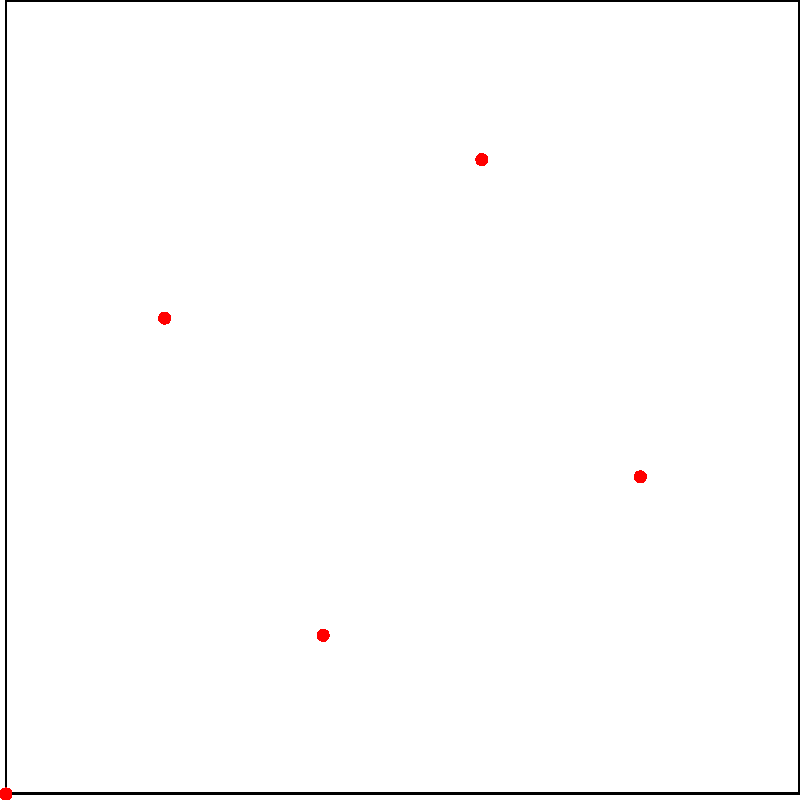На футбольном поле размером 5x5 расположены пять игроков (A, B, C, D, E) в различных позициях, как показано на диаграмме. Используя диаграмму Вороного, определите, какой игрок контролирует наибольшую площадь поля. Предположим, что все игроки имеют одинаковую скорость и способность покрывать территорию. Чтобы решить эту задачу, давайте разберем ее по шагам:

1) Диаграмма Вороного разделяет поле на области, где каждая точка в области ближе к соответствующему игроку, чем к любому другому.

2) Анализируя диаграмму, мы видим, что поле разделено на 5 областей, каждая соответствует одному игроку.

3) Чтобы определить, кто контролирует наибольшую площадь, нужно сравнить размеры областей Вороного для каждого игрока.

4) Визуально оценивая области:
   - Игрок A контролирует нижний левый угол
   - Игрок B имеет небольшую область в центре
   - Игрок C контролирует верхнюю левую часть
   - Игрок D имеет большую область в правой части поля
   - Игрок E контролирует верхнюю правую часть

5) Сравнивая эти области, видно, что область игрока D занимает наибольшую часть поля.

Таким образом, игрок D контролирует наибольшую площадь на поле согласно диаграмме Вороного.
Answer: Игрок D 